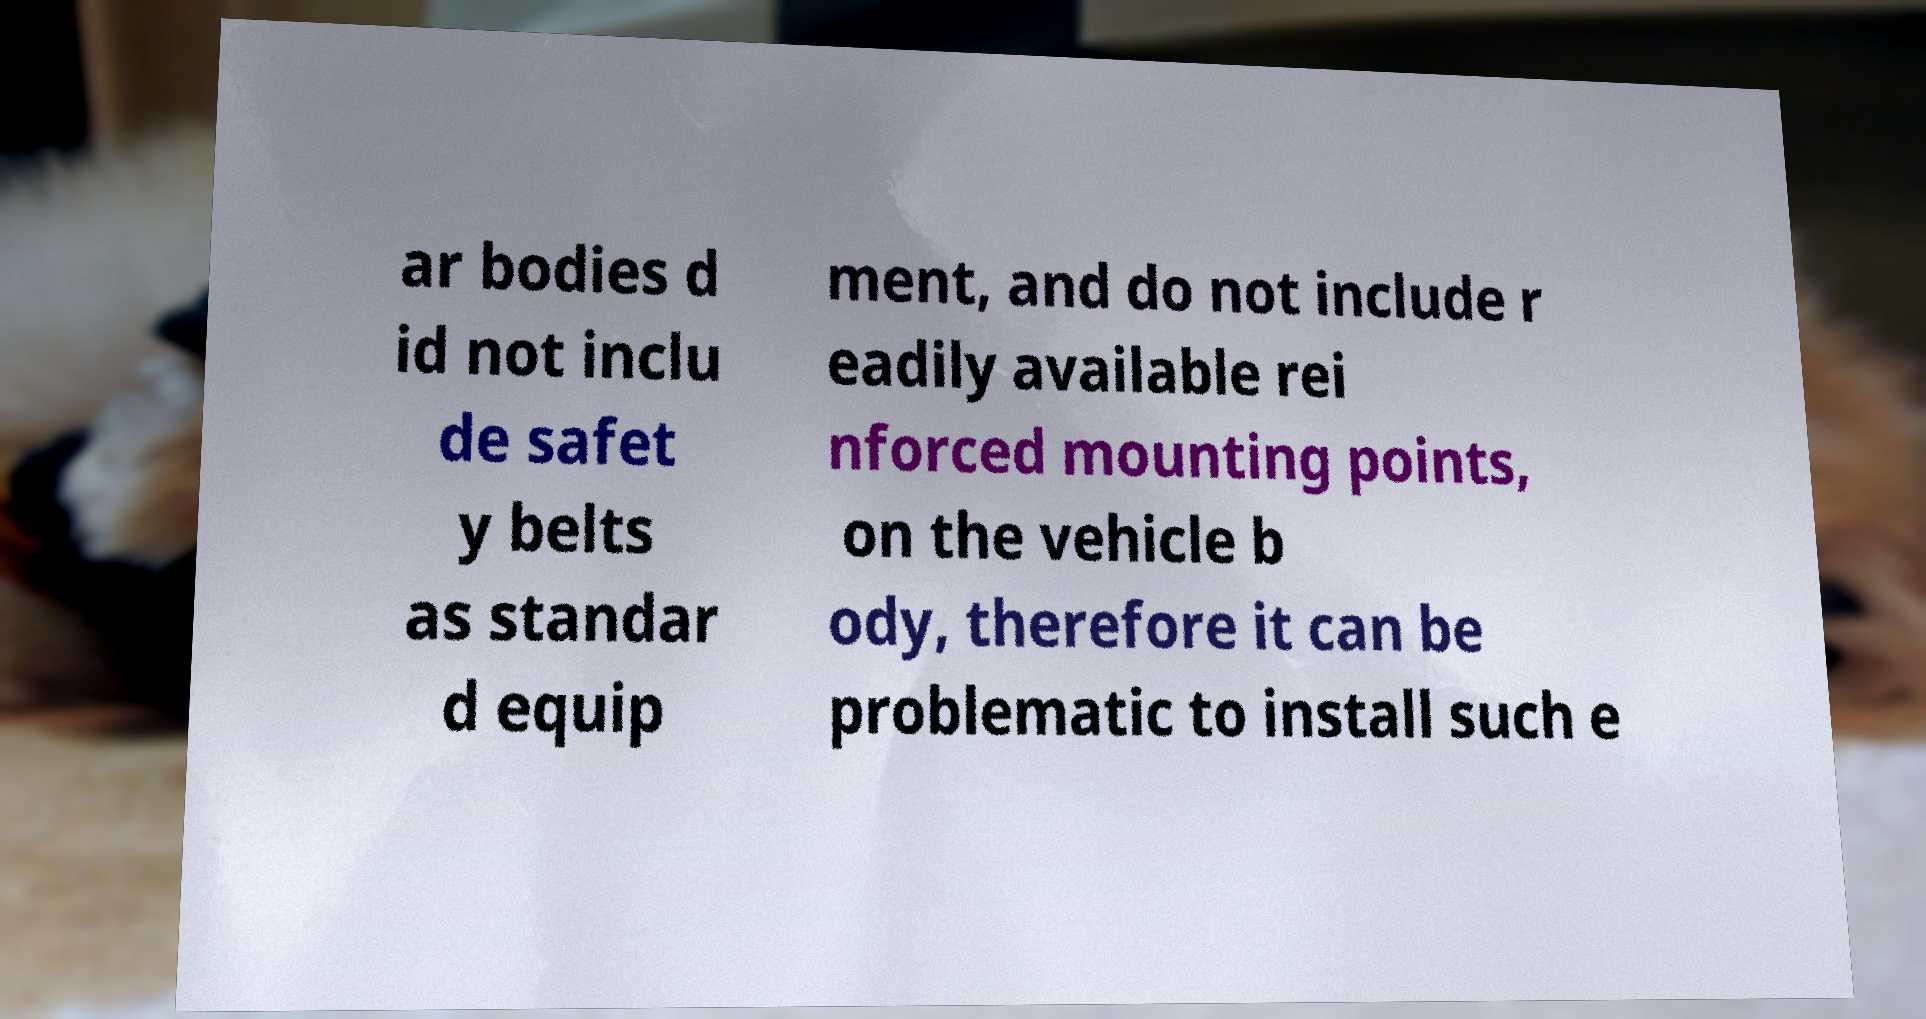Please identify and transcribe the text found in this image. ar bodies d id not inclu de safet y belts as standar d equip ment, and do not include r eadily available rei nforced mounting points, on the vehicle b ody, therefore it can be problematic to install such e 